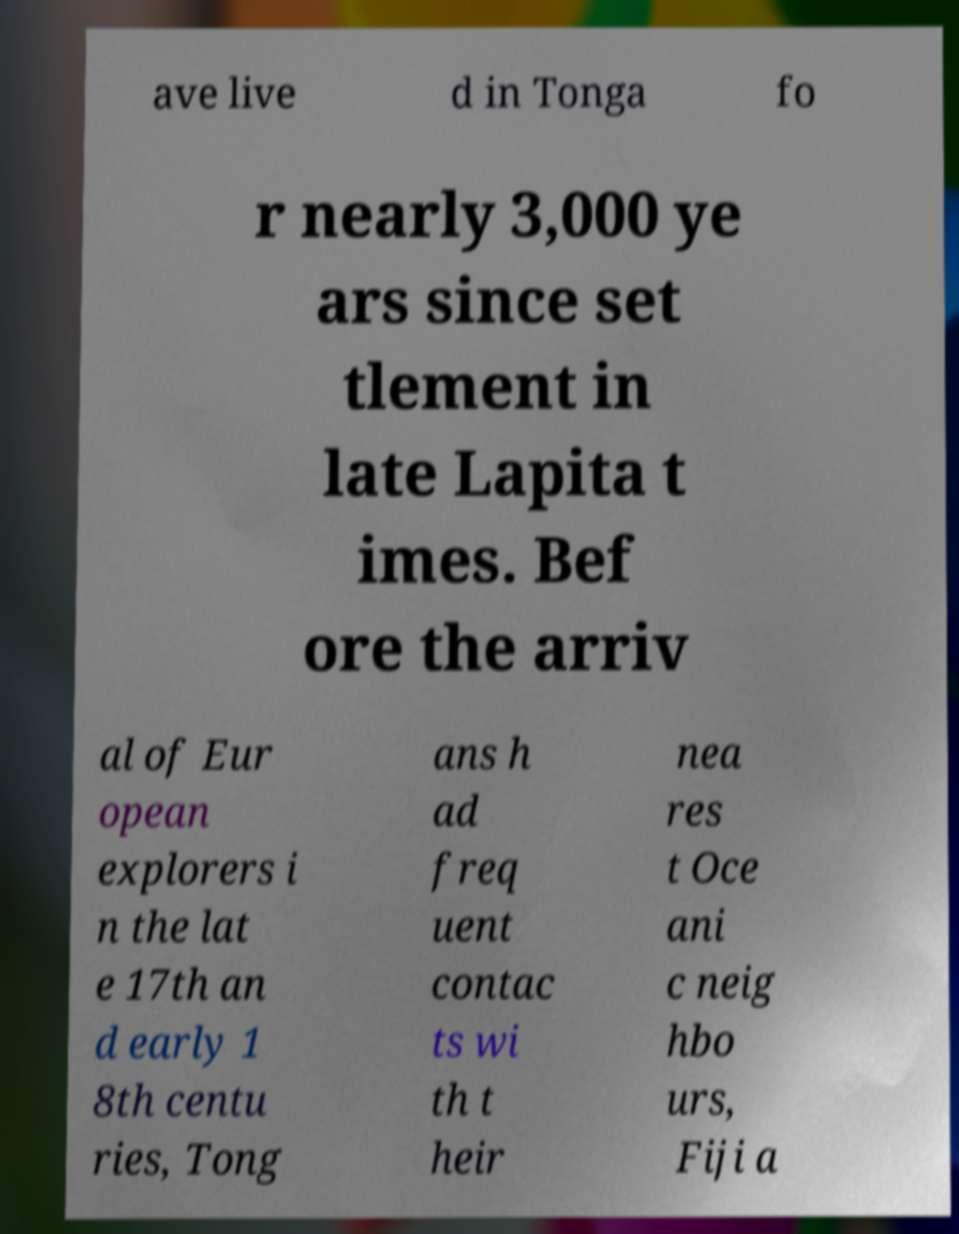Can you accurately transcribe the text from the provided image for me? ave live d in Tonga fo r nearly 3,000 ye ars since set tlement in late Lapita t imes. Bef ore the arriv al of Eur opean explorers i n the lat e 17th an d early 1 8th centu ries, Tong ans h ad freq uent contac ts wi th t heir nea res t Oce ani c neig hbo urs, Fiji a 